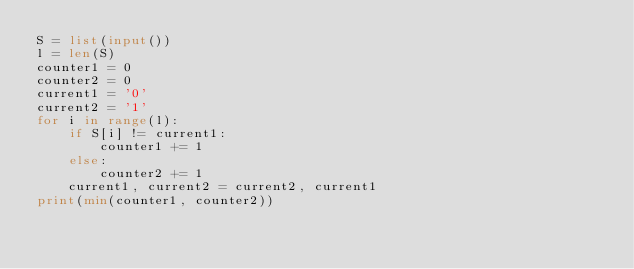<code> <loc_0><loc_0><loc_500><loc_500><_Python_>S = list(input())
l = len(S)
counter1 = 0
counter2 = 0
current1 = '0'
current2 = '1'
for i in range(l):
    if S[i] != current1:
        counter1 += 1
    else:
        counter2 += 1
    current1, current2 = current2, current1
print(min(counter1, counter2))</code> 